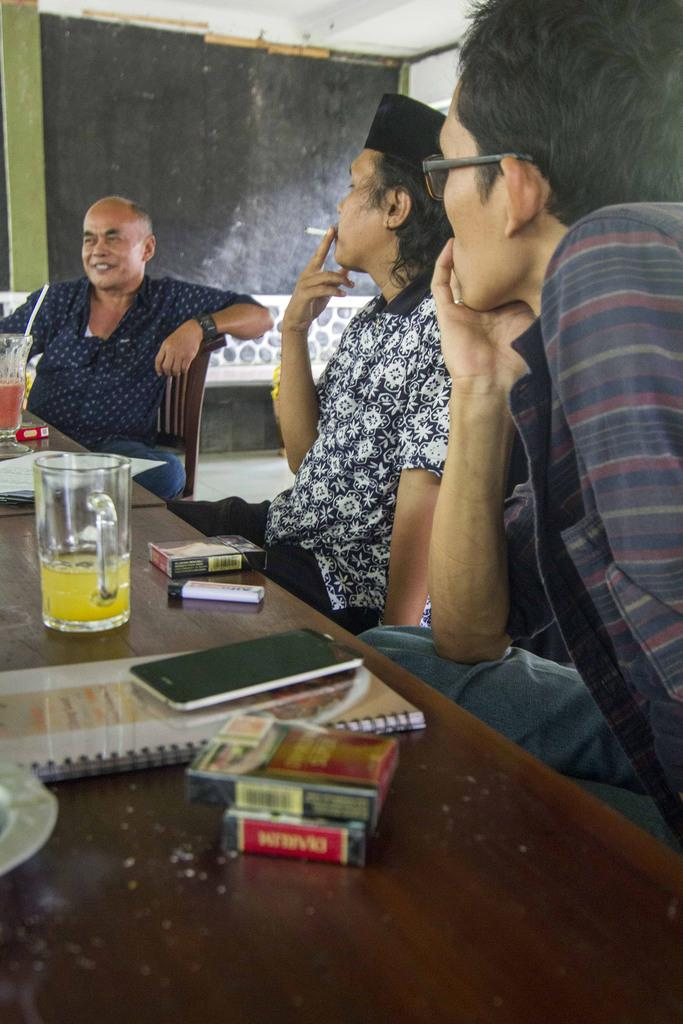How many men are in the image? There are three men in the image. What are the men doing in the image? The men are sitting on chairs. Is there any activity involving one of the men? Yes, one of the men is smoking. What can be seen on the table in the image? There is a table in the image with lots of books, a glass of juice, a cell phone, and another glass of juice on it. What type of stew is being served in the image? There is no stew present in the image. Can you tell me what time it is based on the clock in the image? There is no clock present in the image. 